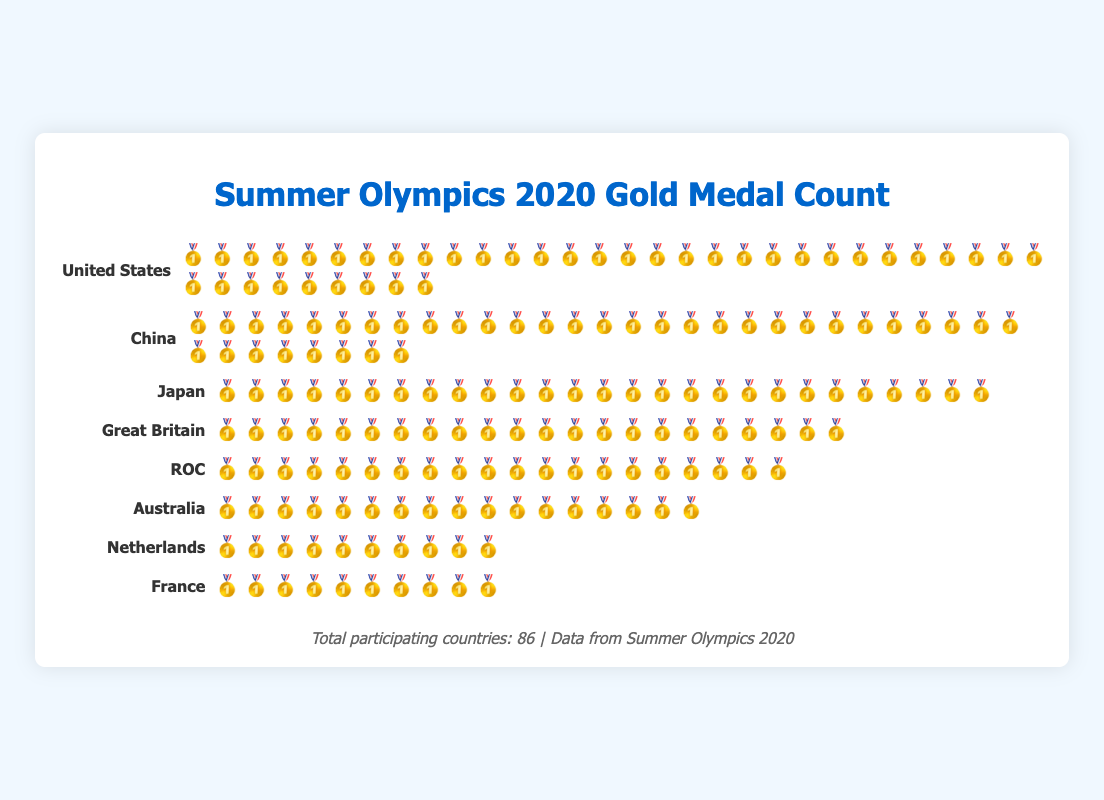Which country won the most gold medals in the Summer Olympics 2020? By counting the gold medal icons in each row, it is clear that the United States has the most with 39 gold medals.
Answer: United States What is the total number of gold medals won by Japan and Great Britain combined? Japan won 27 gold medals, and Great Britain won 22. Adding them together gives 27 + 22 = 49 gold medals.
Answer: 49 How many more gold medals did the United States win compared to Australia? The United States won 39 gold medals, while Australia won 17. Subtracting 17 from 39 gives 39 - 17 = 22.
Answer: 22 Which two countries have the same number of gold medals? The countries whose rows contain an equal number of gold medal icons are the Netherlands and France, each having 10 gold medals.
Answer: Netherlands and France Rank the top three countries based on their gold medal counts. By counting the gold medal icons in each row: 1st is United States with 39, 2nd is China with 38, and 3rd is Japan with 27.
Answer: United States, China, Japan How many gold medals were awarded to the top-performing countries listed in the plot in total? Summing the gold medals from each country: 39 (US) + 38 (China) + 27 (Japan) + 22 (Great Britain) + 20 (ROC) + 17 (Australia) + 10 (Netherlands) + 10 (France) = 183.
Answer: 183 How does China’s gold medal count compare to ROC’s? China won 38 gold medals while ROC won 20. By comparing the numbers directly, China has 18 more gold medals than ROC.
Answer: 18 more Identify the country that occupies the 5th position in the gold medal ranking. By counting the gold medals and ranking countries: 1st is United States, 2nd is China, 3rd is Japan, 4th is Great Britain, and 5th is ROC.
Answer: ROC Which country won fewer gold medals: Japan or Australia? Comparing the two, Japan won 27 gold medals while Australia won 17. Australia won fewer gold medals than Japan.
Answer: Australia How does the total number of participating countries relate to the top-performing ones listed in the plot? The footer mentions there are 86 participating countries total. The plot lists only the top eight countries by gold medal count. This shows that only a small fraction of participating countries won large numbers of gold medals.
Answer: 86 participating, 8 top-performing 